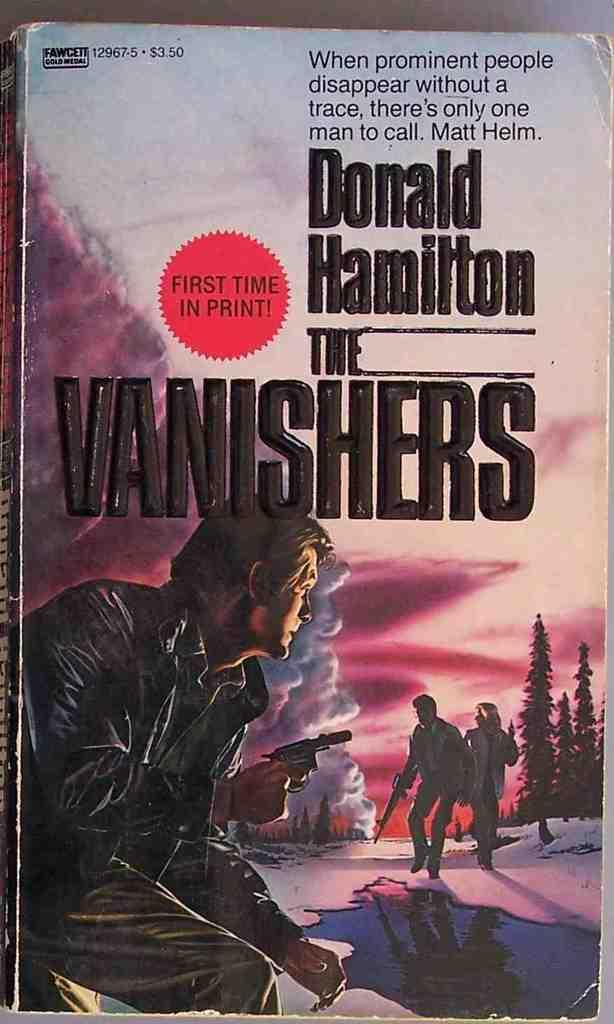<image>
Describe the image concisely. Book cover for The Vanishers by Doanld Hamilton showing a man holding a gun. 